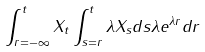Convert formula to latex. <formula><loc_0><loc_0><loc_500><loc_500>\int _ { r = - \infty } ^ { t } X _ { t } \int _ { s = r } ^ { t } \lambda X _ { s } d s \lambda e ^ { \lambda r } d r</formula> 